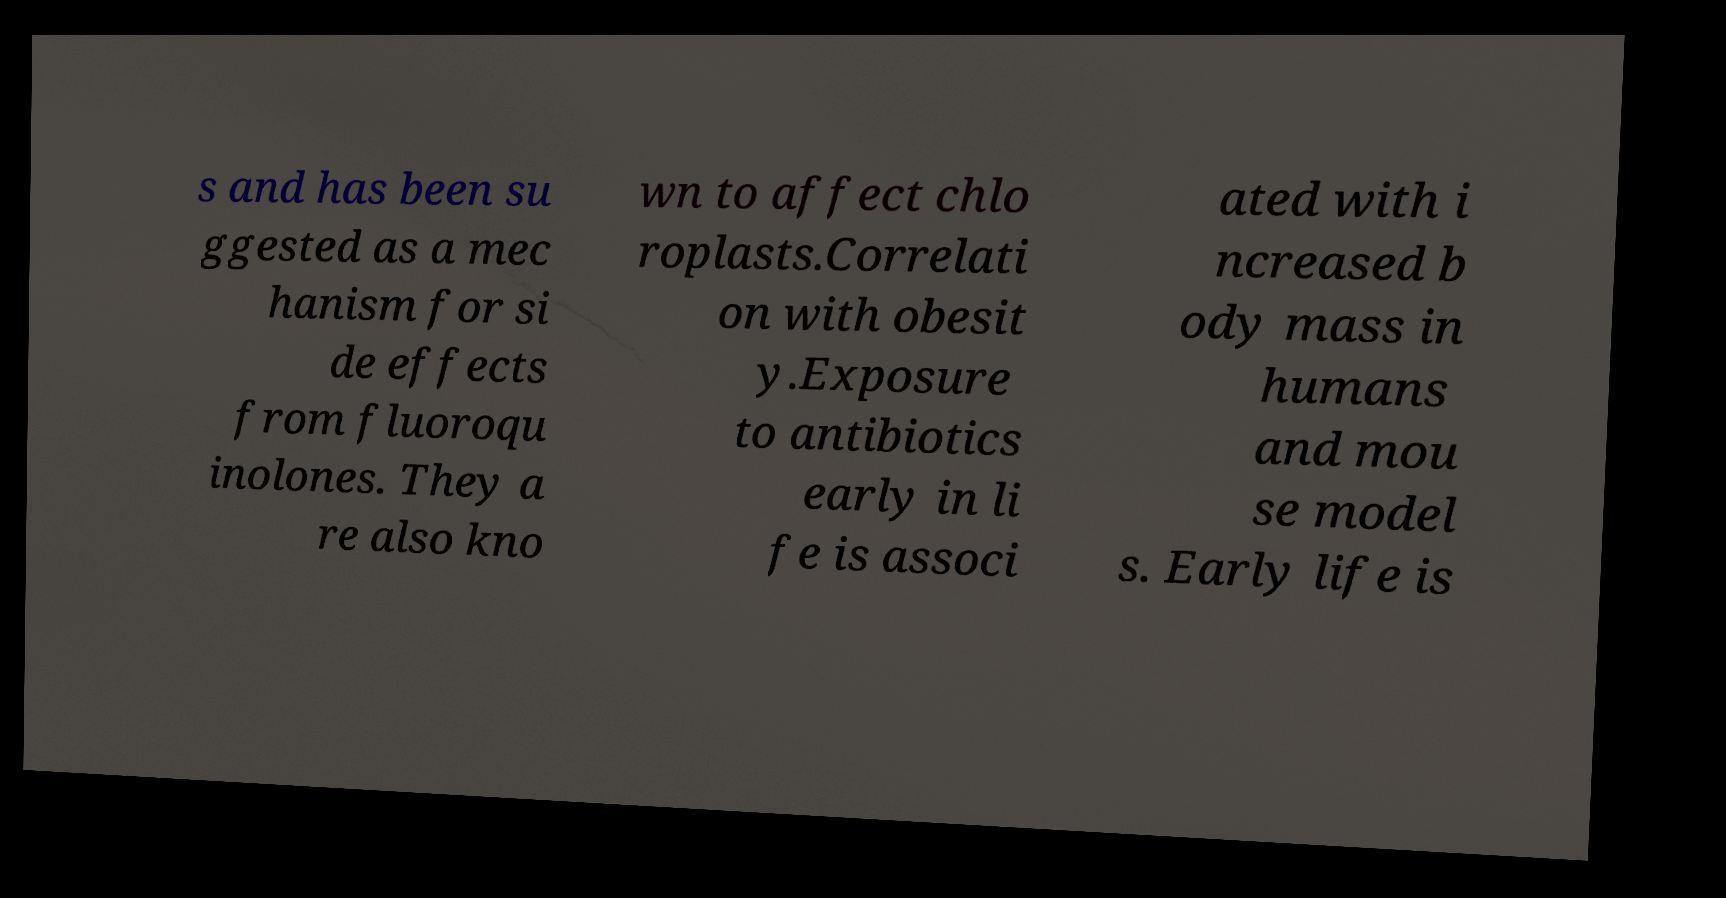Can you accurately transcribe the text from the provided image for me? s and has been su ggested as a mec hanism for si de effects from fluoroqu inolones. They a re also kno wn to affect chlo roplasts.Correlati on with obesit y.Exposure to antibiotics early in li fe is associ ated with i ncreased b ody mass in humans and mou se model s. Early life is 